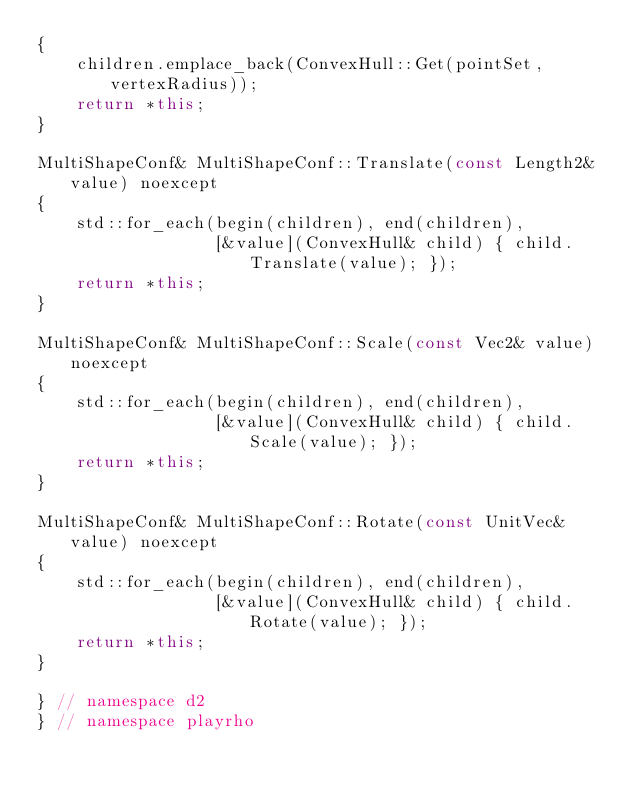Convert code to text. <code><loc_0><loc_0><loc_500><loc_500><_C++_>{
    children.emplace_back(ConvexHull::Get(pointSet, vertexRadius));
    return *this;
}

MultiShapeConf& MultiShapeConf::Translate(const Length2& value) noexcept
{
    std::for_each(begin(children), end(children),
                  [&value](ConvexHull& child) { child.Translate(value); });
    return *this;
}

MultiShapeConf& MultiShapeConf::Scale(const Vec2& value) noexcept
{
    std::for_each(begin(children), end(children),
                  [&value](ConvexHull& child) { child.Scale(value); });
    return *this;
}

MultiShapeConf& MultiShapeConf::Rotate(const UnitVec& value) noexcept
{
    std::for_each(begin(children), end(children),
                  [&value](ConvexHull& child) { child.Rotate(value); });
    return *this;
}

} // namespace d2
} // namespace playrho
</code> 